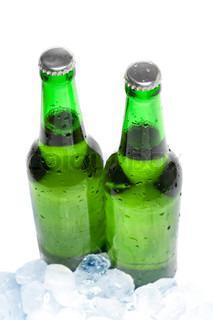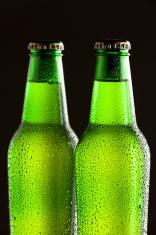The first image is the image on the left, the second image is the image on the right. Given the left and right images, does the statement "Neither individual image includes more than two bottles." hold true? Answer yes or no. Yes. The first image is the image on the left, the second image is the image on the right. Analyze the images presented: Is the assertion "Two green bottles are sitting near some ice." valid? Answer yes or no. Yes. 